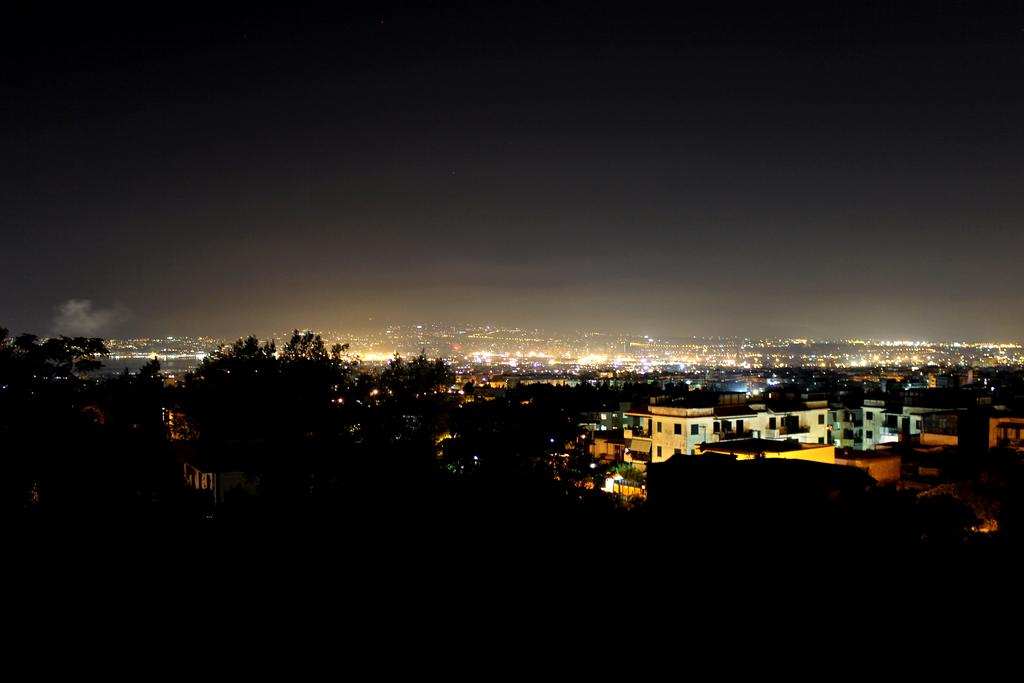What type of natural elements can be seen in the background of the image? There are trees in the background of the image. What type of man-made structures are visible in the background of the image? There are buildings in the background of the image. What type of illumination is present in the background of the image? Lights are present in the background of the image. What is the condition of the sky in the image? The sky is clear in the image. How would you describe the lighting in the foreground of the image? The foreground of the image is dark. How many dogs are sitting on the coach in the image? There are no dogs or coaches present in the image. What type of statement is written on the trees in the image? There are no statements written on the trees in the image; only trees, buildings, lights, and a clear sky are visible. 